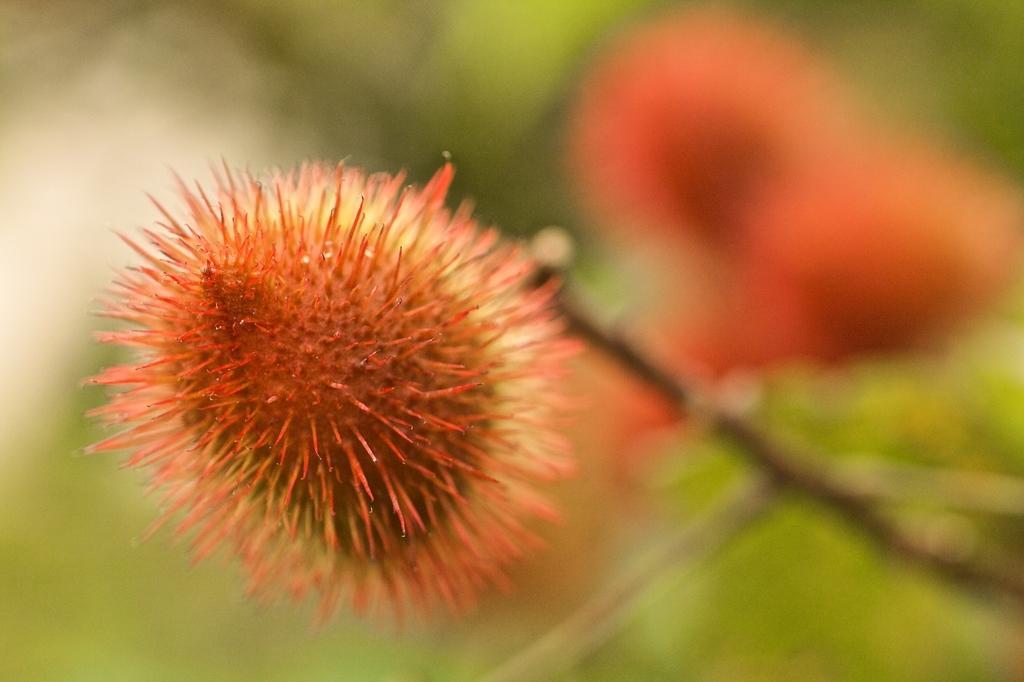Please provide a concise description of this image. In the picture we can see some flower which is red in color and the background image is blur. 